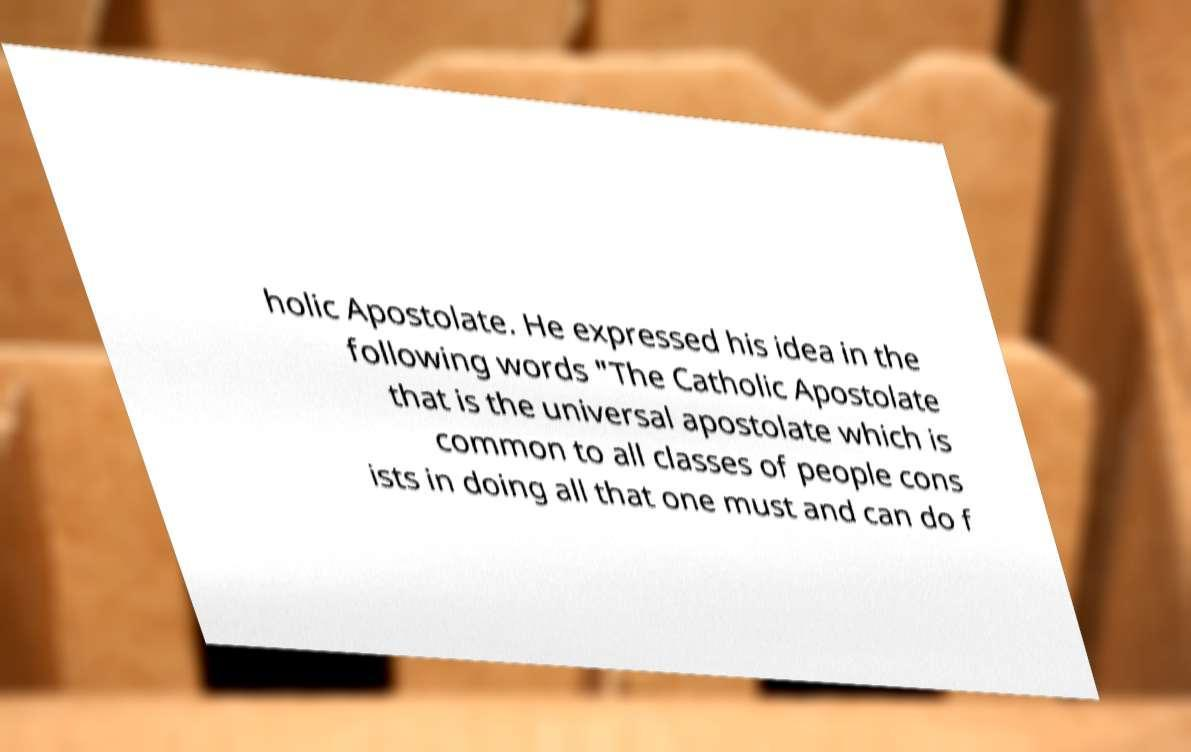There's text embedded in this image that I need extracted. Can you transcribe it verbatim? holic Apostolate. He expressed his idea in the following words "The Catholic Apostolate that is the universal apostolate which is common to all classes of people cons ists in doing all that one must and can do f 